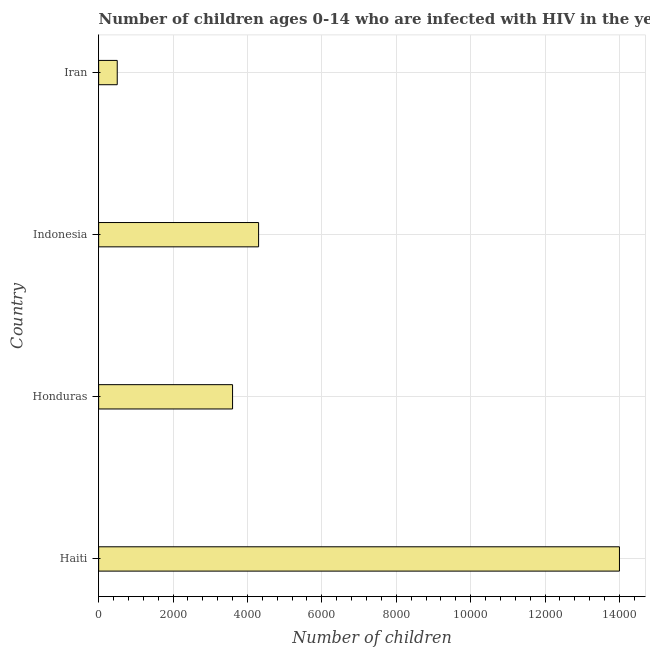What is the title of the graph?
Your answer should be compact. Number of children ages 0-14 who are infected with HIV in the year 2006. What is the label or title of the X-axis?
Offer a terse response. Number of children. What is the number of children living with hiv in Iran?
Make the answer very short. 500. Across all countries, what is the maximum number of children living with hiv?
Your answer should be very brief. 1.40e+04. Across all countries, what is the minimum number of children living with hiv?
Your answer should be compact. 500. In which country was the number of children living with hiv maximum?
Your response must be concise. Haiti. In which country was the number of children living with hiv minimum?
Your response must be concise. Iran. What is the sum of the number of children living with hiv?
Ensure brevity in your answer.  2.24e+04. What is the difference between the number of children living with hiv in Haiti and Indonesia?
Make the answer very short. 9700. What is the average number of children living with hiv per country?
Provide a succinct answer. 5600. What is the median number of children living with hiv?
Keep it short and to the point. 3950. What is the ratio of the number of children living with hiv in Indonesia to that in Iran?
Your response must be concise. 8.6. What is the difference between the highest and the second highest number of children living with hiv?
Provide a short and direct response. 9700. What is the difference between the highest and the lowest number of children living with hiv?
Your response must be concise. 1.35e+04. How many countries are there in the graph?
Your answer should be compact. 4. What is the difference between two consecutive major ticks on the X-axis?
Offer a terse response. 2000. Are the values on the major ticks of X-axis written in scientific E-notation?
Keep it short and to the point. No. What is the Number of children of Haiti?
Ensure brevity in your answer.  1.40e+04. What is the Number of children in Honduras?
Offer a terse response. 3600. What is the Number of children in Indonesia?
Provide a succinct answer. 4300. What is the Number of children of Iran?
Provide a short and direct response. 500. What is the difference between the Number of children in Haiti and Honduras?
Your answer should be compact. 1.04e+04. What is the difference between the Number of children in Haiti and Indonesia?
Your answer should be very brief. 9700. What is the difference between the Number of children in Haiti and Iran?
Your answer should be very brief. 1.35e+04. What is the difference between the Number of children in Honduras and Indonesia?
Ensure brevity in your answer.  -700. What is the difference between the Number of children in Honduras and Iran?
Your answer should be very brief. 3100. What is the difference between the Number of children in Indonesia and Iran?
Make the answer very short. 3800. What is the ratio of the Number of children in Haiti to that in Honduras?
Your response must be concise. 3.89. What is the ratio of the Number of children in Haiti to that in Indonesia?
Your response must be concise. 3.26. What is the ratio of the Number of children in Honduras to that in Indonesia?
Your response must be concise. 0.84. What is the ratio of the Number of children in Honduras to that in Iran?
Make the answer very short. 7.2. What is the ratio of the Number of children in Indonesia to that in Iran?
Make the answer very short. 8.6. 